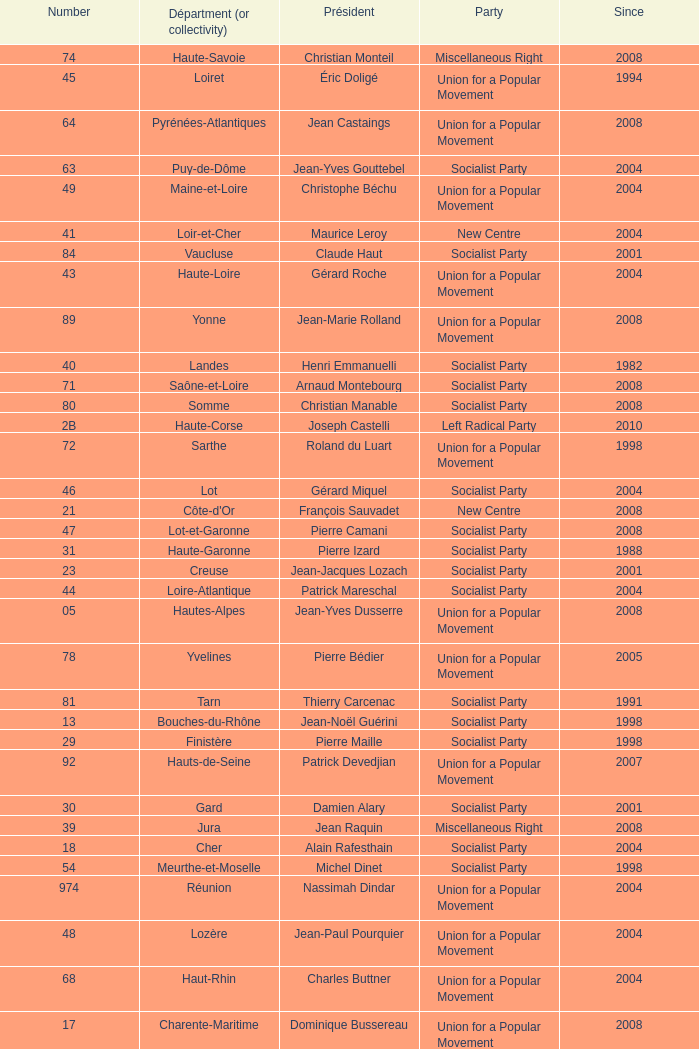Who is the president for the creuse department? Jean-Jacques Lozach. 